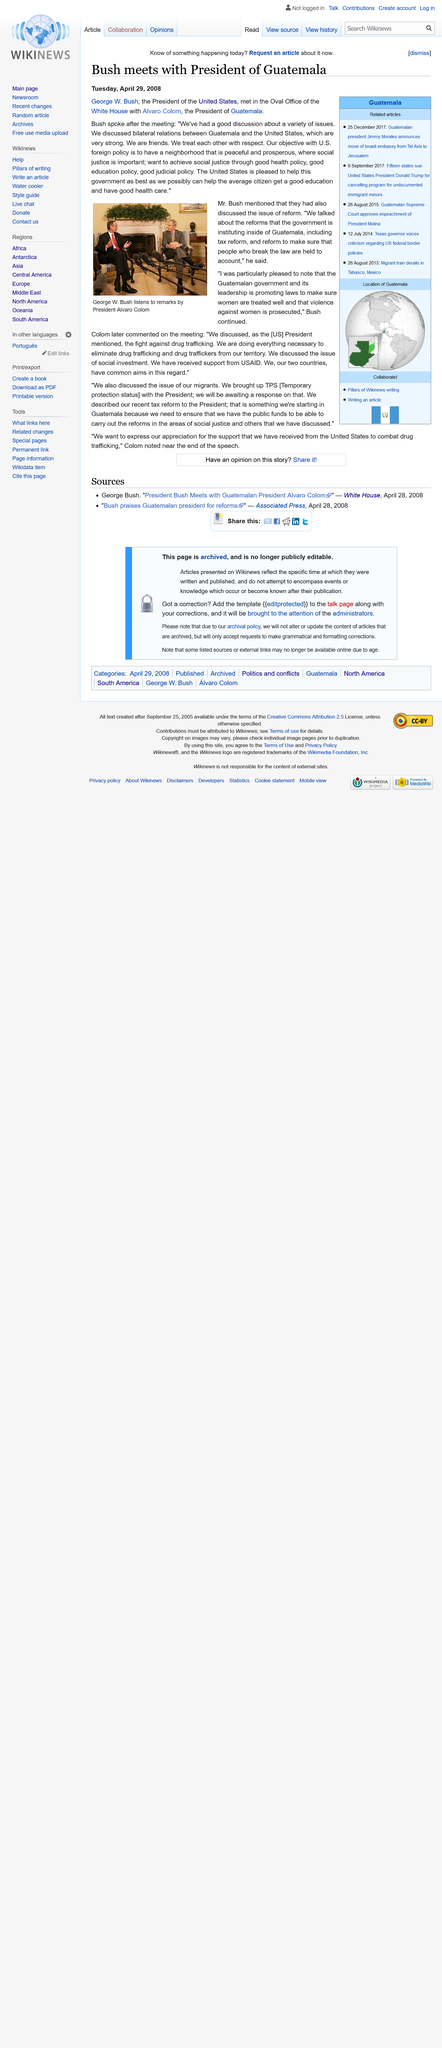Mention a couple of crucial points in this snapshot. The article "Bush meets with President of Guatemala" was published on Tuesday April 29, 2008. The President of the United States was George W. Bush. Alvaro Colom was the President of Guatemala. 